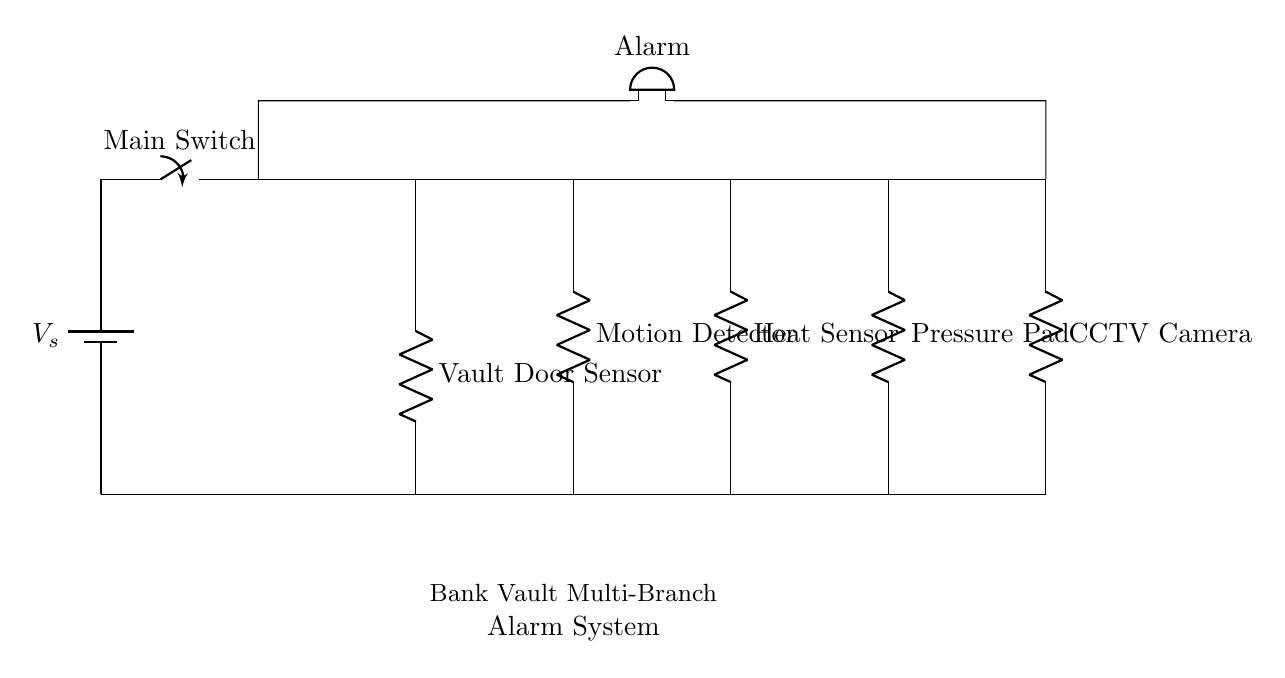What is the main power source for this alarm system? The alarm system is powered by a battery, indicated by the component labeled 'V_s'. It is positioned at the top left of the circuit diagram.
Answer: battery How many sensors are connected in this alarm system? There are five sensors connected in this circuit: the Vault Door Sensor, Motion Detector, Heat Sensor, Pressure Pad, and CCTV Camera. These are highlighted with 'R' in the circuit.
Answer: five What would happen if the Main Switch is turned off? If the Main Switch is turned off, the entire circuit is interrupted, resulting in no power to any of the sensors and therefore no triggering of the alarm system.
Answer: alarm off Which component activates the alarm? The component labeled ‘Alarm’ (buzzer) is what activates when the circuit is completed by any triggered sensor. This indicates an alert situation, corresponding to any security breach.
Answer: Alarm If one sensor is triggered, how many alarms will sound? In a parallel circuit, if one sensor is triggered, the alarm will sound one time, as the alarm is connected to all branches and is activated by any sensor signal.
Answer: one What is the type of this alarm system's circuit configuration? The circuit diagram shows a parallel configuration as all sensors are connected to the same voltage source and can operate independently without affecting each other's function.
Answer: parallel 